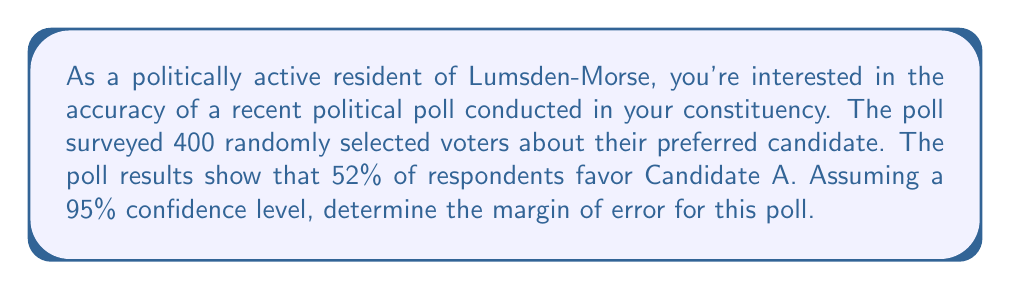Help me with this question. To determine the margin of error for this political poll, we'll follow these steps:

1) The margin of error formula for a 95% confidence interval is:

   $$ME = z^* \sqrt{\frac{p(1-p)}{n}}$$

   Where:
   - $ME$ is the margin of error
   - $z^*$ is the critical value (1.96 for 95% confidence)
   - $p$ is the sample proportion
   - $n$ is the sample size

2) We know:
   - $z^* = 1.96$ (for 95% confidence)
   - $p = 0.52$ (52% favor Candidate A)
   - $n = 400$ (sample size)

3) Let's substitute these values into the formula:

   $$ME = 1.96 \sqrt{\frac{0.52(1-0.52)}{400}}$$

4) Simplify inside the square root:

   $$ME = 1.96 \sqrt{\frac{0.52(0.48)}{400}}$$

5) Calculate:

   $$ME = 1.96 \sqrt{\frac{0.2496}{400}} = 1.96 \sqrt{0.000624} = 1.96 (0.02498)$$

6) Final calculation:

   $$ME = 0.04896 \approx 0.049 \text{ or } 4.9\%$$

Therefore, the margin of error for this poll is approximately 4.9%.
Answer: 4.9% 